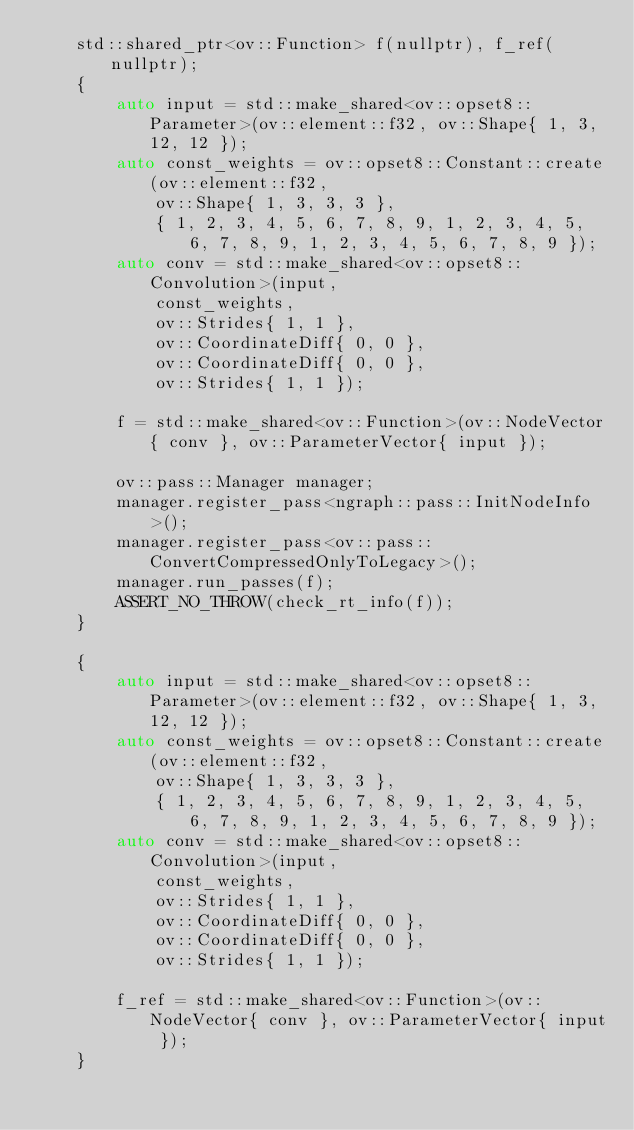Convert code to text. <code><loc_0><loc_0><loc_500><loc_500><_C++_>    std::shared_ptr<ov::Function> f(nullptr), f_ref(nullptr);
    {
        auto input = std::make_shared<ov::opset8::Parameter>(ov::element::f32, ov::Shape{ 1, 3, 12, 12 });
        auto const_weights = ov::opset8::Constant::create(ov::element::f32,
            ov::Shape{ 1, 3, 3, 3 },
            { 1, 2, 3, 4, 5, 6, 7, 8, 9, 1, 2, 3, 4, 5, 6, 7, 8, 9, 1, 2, 3, 4, 5, 6, 7, 8, 9 });
        auto conv = std::make_shared<ov::opset8::Convolution>(input,
            const_weights,
            ov::Strides{ 1, 1 },
            ov::CoordinateDiff{ 0, 0 },
            ov::CoordinateDiff{ 0, 0 },
            ov::Strides{ 1, 1 });

        f = std::make_shared<ov::Function>(ov::NodeVector{ conv }, ov::ParameterVector{ input });

        ov::pass::Manager manager;
        manager.register_pass<ngraph::pass::InitNodeInfo>();
        manager.register_pass<ov::pass::ConvertCompressedOnlyToLegacy>();
        manager.run_passes(f);
        ASSERT_NO_THROW(check_rt_info(f));
    }

    {
        auto input = std::make_shared<ov::opset8::Parameter>(ov::element::f32, ov::Shape{ 1, 3, 12, 12 });
        auto const_weights = ov::opset8::Constant::create(ov::element::f32,
            ov::Shape{ 1, 3, 3, 3 },
            { 1, 2, 3, 4, 5, 6, 7, 8, 9, 1, 2, 3, 4, 5, 6, 7, 8, 9, 1, 2, 3, 4, 5, 6, 7, 8, 9 });
        auto conv = std::make_shared<ov::opset8::Convolution>(input,
            const_weights,
            ov::Strides{ 1, 1 },
            ov::CoordinateDiff{ 0, 0 },
            ov::CoordinateDiff{ 0, 0 },
            ov::Strides{ 1, 1 });

        f_ref = std::make_shared<ov::Function>(ov::NodeVector{ conv }, ov::ParameterVector{ input });
    }
</code> 